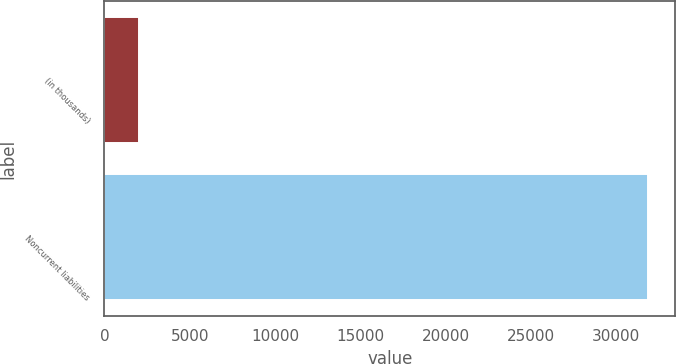<chart> <loc_0><loc_0><loc_500><loc_500><bar_chart><fcel>(in thousands)<fcel>Noncurrent liabilities<nl><fcel>2011<fcel>31867<nl></chart> 